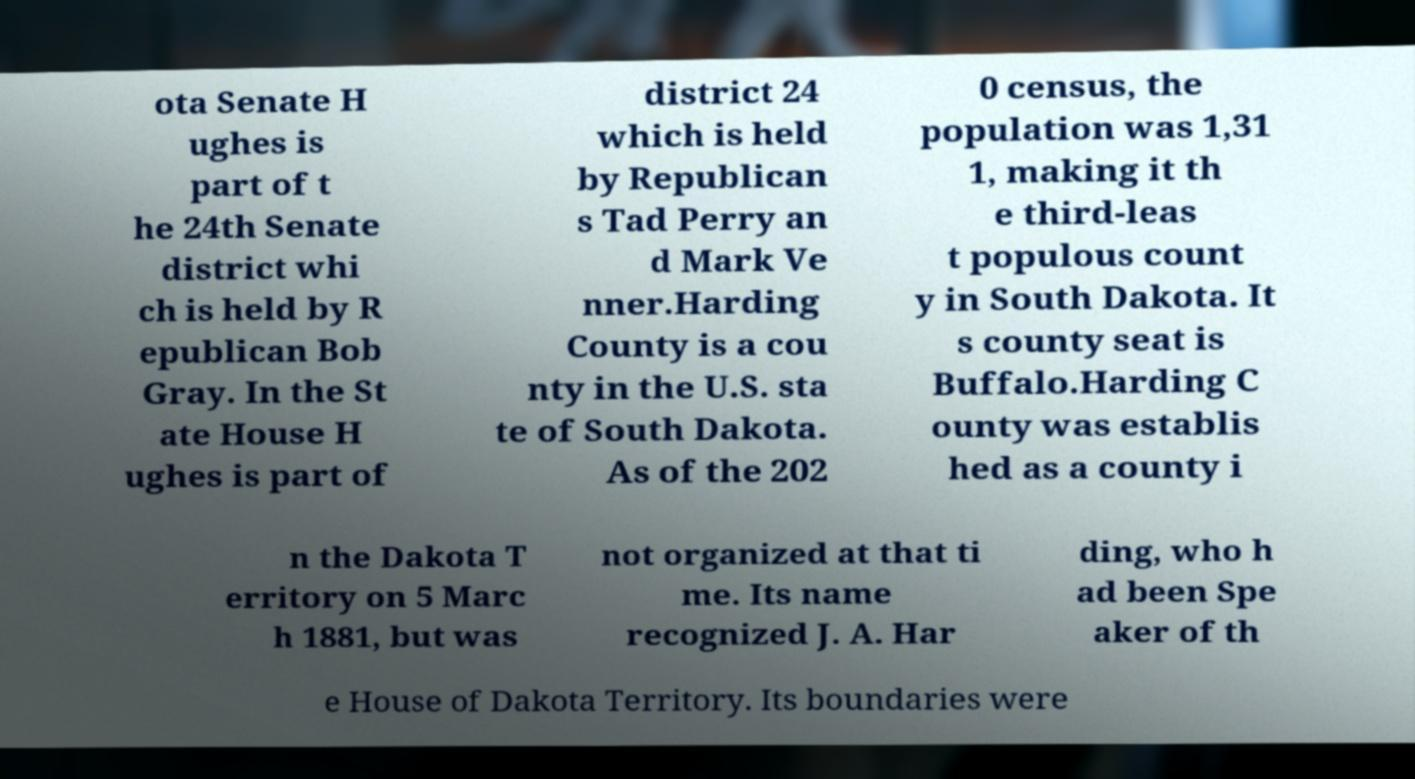Could you extract and type out the text from this image? ota Senate H ughes is part of t he 24th Senate district whi ch is held by R epublican Bob Gray. In the St ate House H ughes is part of district 24 which is held by Republican s Tad Perry an d Mark Ve nner.Harding County is a cou nty in the U.S. sta te of South Dakota. As of the 202 0 census, the population was 1,31 1, making it th e third-leas t populous count y in South Dakota. It s county seat is Buffalo.Harding C ounty was establis hed as a county i n the Dakota T erritory on 5 Marc h 1881, but was not organized at that ti me. Its name recognized J. A. Har ding, who h ad been Spe aker of th e House of Dakota Territory. Its boundaries were 